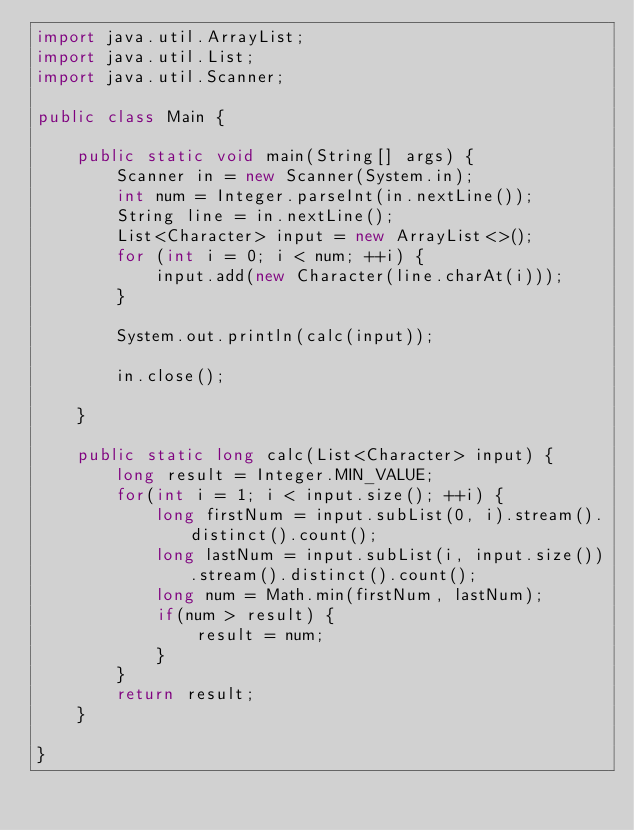<code> <loc_0><loc_0><loc_500><loc_500><_Java_>import java.util.ArrayList;
import java.util.List;
import java.util.Scanner;

public class Main {

	public static void main(String[] args) {
		Scanner in = new Scanner(System.in);
		int num = Integer.parseInt(in.nextLine());
		String line = in.nextLine();
		List<Character> input = new ArrayList<>();
		for (int i = 0; i < num; ++i) {
			input.add(new Character(line.charAt(i)));
		}
		
		System.out.println(calc(input));

		in.close();

	}

	public static long calc(List<Character> input) {
		long result = Integer.MIN_VALUE;
		for(int i = 1; i < input.size(); ++i) {
			long firstNum = input.subList(0, i).stream().distinct().count();
			long lastNum = input.subList(i, input.size()).stream().distinct().count();
			long num = Math.min(firstNum, lastNum);
			if(num > result) {
				result = num;
			}
		}
		return result;
	}

}
</code> 